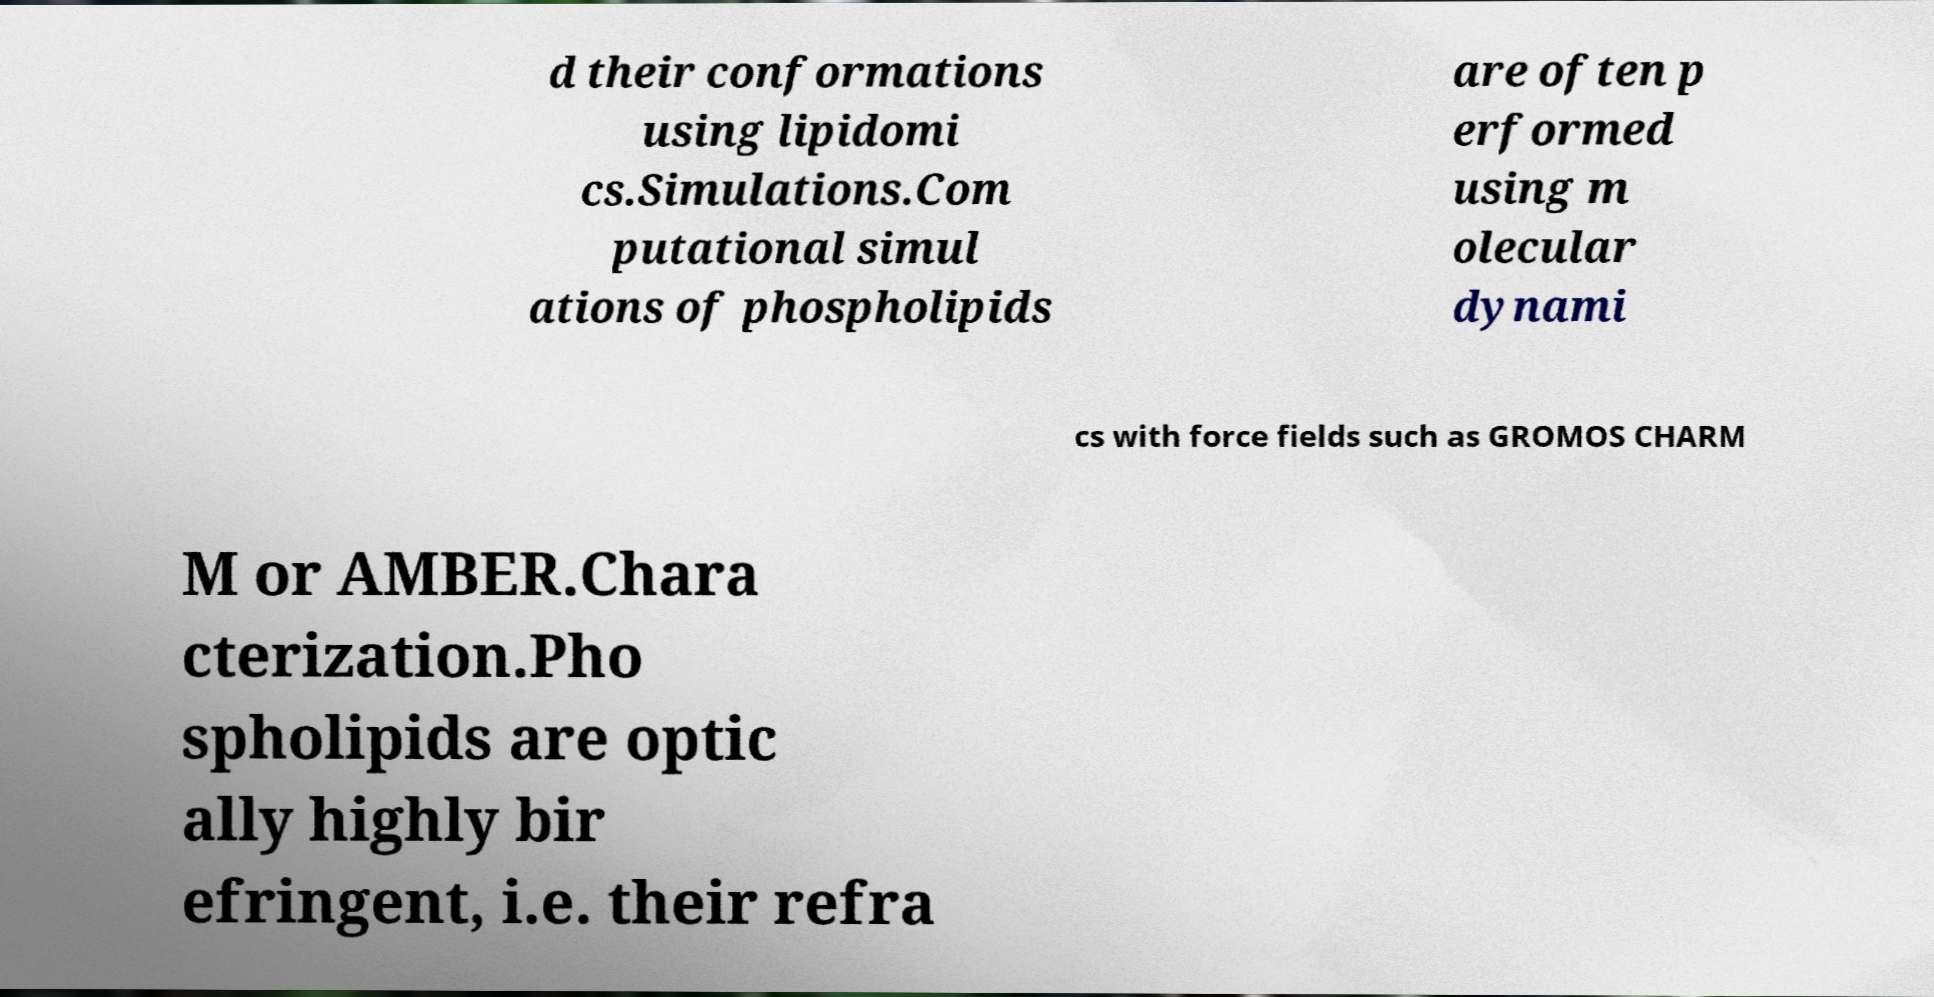Please identify and transcribe the text found in this image. d their conformations using lipidomi cs.Simulations.Com putational simul ations of phospholipids are often p erformed using m olecular dynami cs with force fields such as GROMOS CHARM M or AMBER.Chara cterization.Pho spholipids are optic ally highly bir efringent, i.e. their refra 